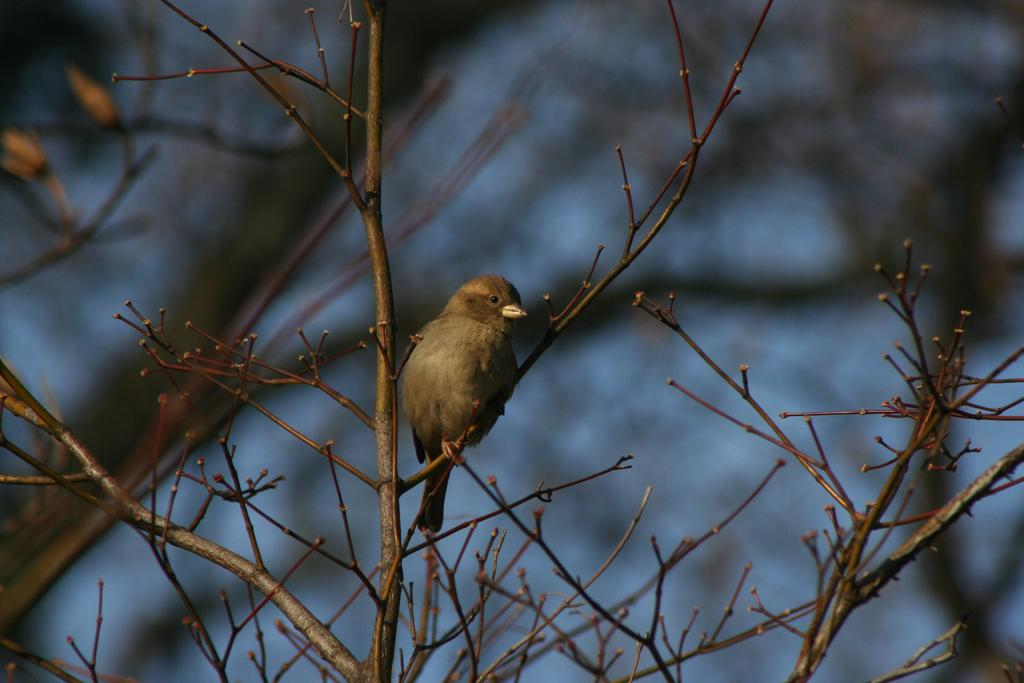What type of animal can be seen in the image? There is a bird in the image. What is the bird perched on in the image? The bird is perched on branches in the image. Can you describe the background of the image? The background of the image is blurry. What word is written on the hill in the image? There is no hill or word present in the image; it features a bird perched on branches with a blurry background. 